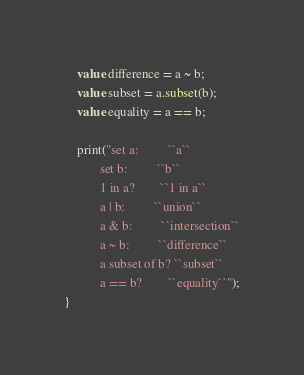<code> <loc_0><loc_0><loc_500><loc_500><_Ceylon_>    value difference = a ~ b;
    value subset = a.subset(b);
    value equality = a == b;

    print("set a:         ``a``
           set b:         ``b``
           1 in a?        ``1 in a``
           a | b:         ``union``
           a & b:         ``intersection``
           a ~ b:         ``difference``
           a subset of b? ``subset``
           a == b?        ``equality``");
}
</code> 